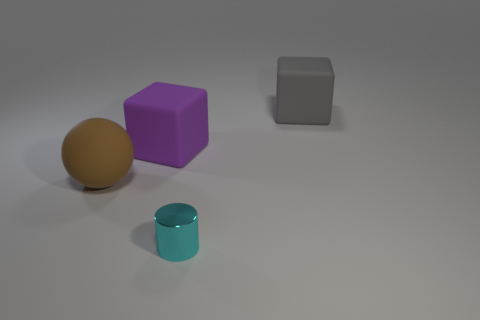Add 3 purple metal objects. How many objects exist? 7 Subtract all balls. How many objects are left? 3 Add 4 large spheres. How many large spheres exist? 5 Subtract 0 purple cylinders. How many objects are left? 4 Subtract all small purple spheres. Subtract all large objects. How many objects are left? 1 Add 2 large rubber balls. How many large rubber balls are left? 3 